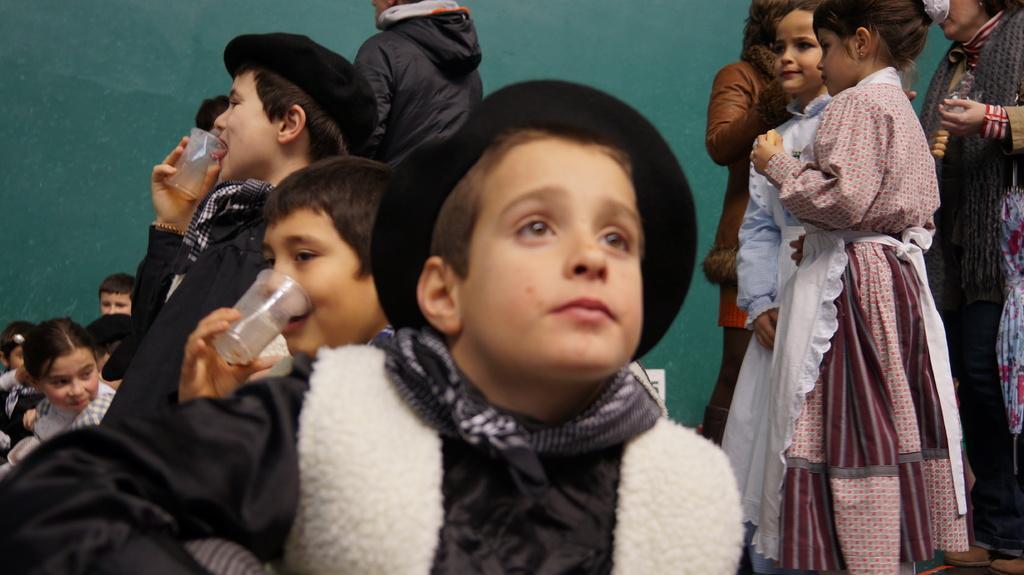How would you summarize this image in a sentence or two? In this picture there is a boy who is wearing hat and sweater. In the back we can see two persons holding the glass. On the right there is a girl who is wearing dress, near to her we can see another girl who is wearing white dress. On the left we can see group of children sitting near to the wall. 